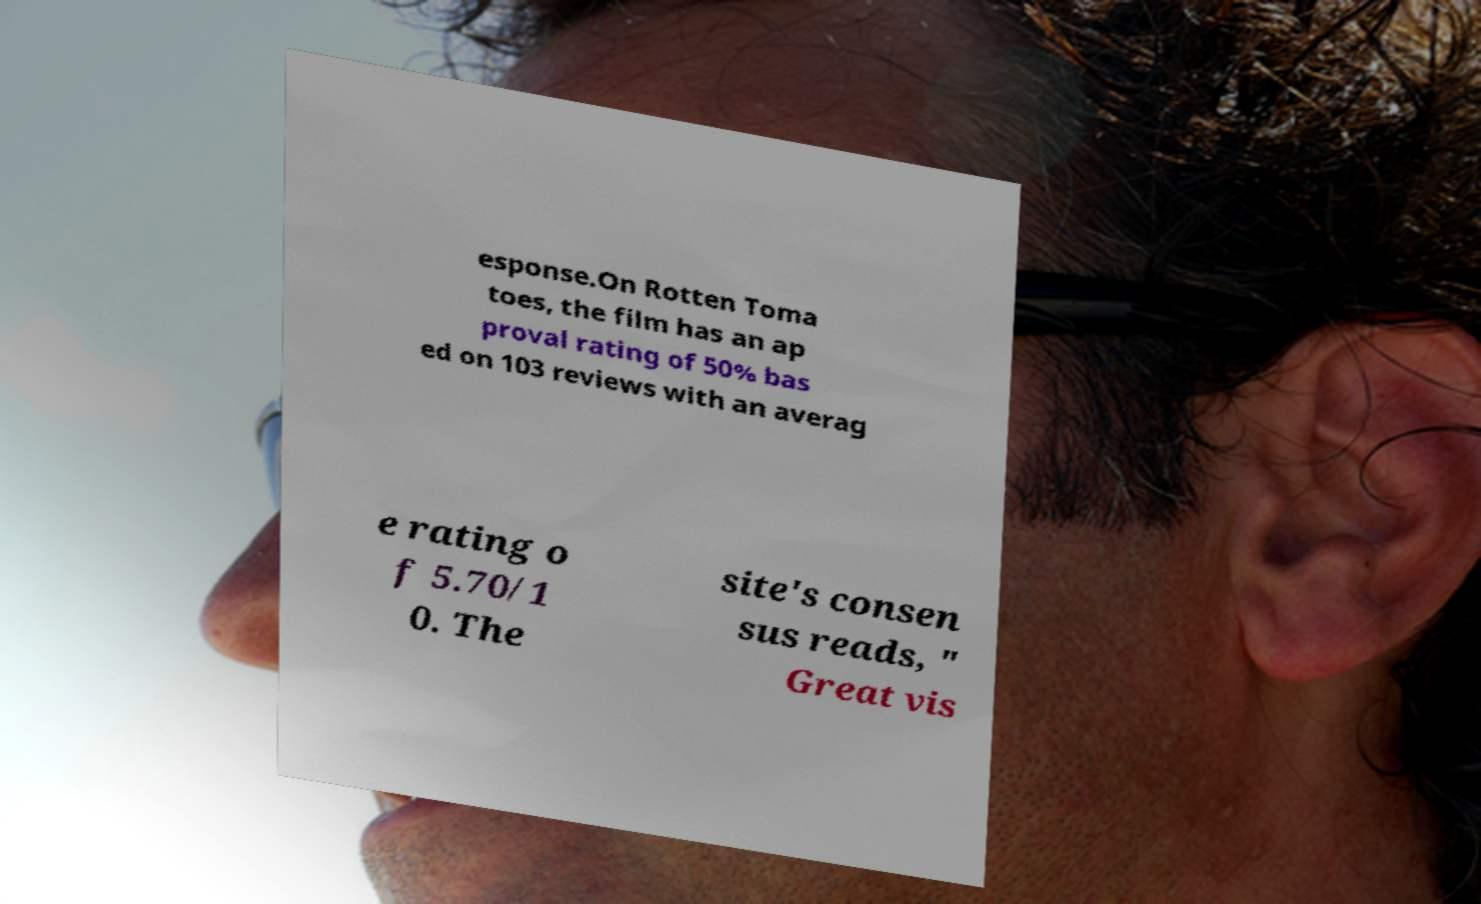What messages or text are displayed in this image? I need them in a readable, typed format. esponse.On Rotten Toma toes, the film has an ap proval rating of 50% bas ed on 103 reviews with an averag e rating o f 5.70/1 0. The site's consen sus reads, " Great vis 